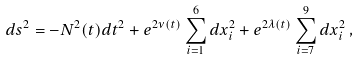Convert formula to latex. <formula><loc_0><loc_0><loc_500><loc_500>d s ^ { 2 } = - N ^ { 2 } ( t ) d t ^ { 2 } + e ^ { 2 \nu ( t ) } \sum ^ { 6 } _ { i = 1 } d x ^ { 2 } _ { i } + e ^ { 2 \lambda ( t ) } \sum ^ { 9 } _ { i = 7 } d x ^ { 2 } _ { i } \, ,</formula> 